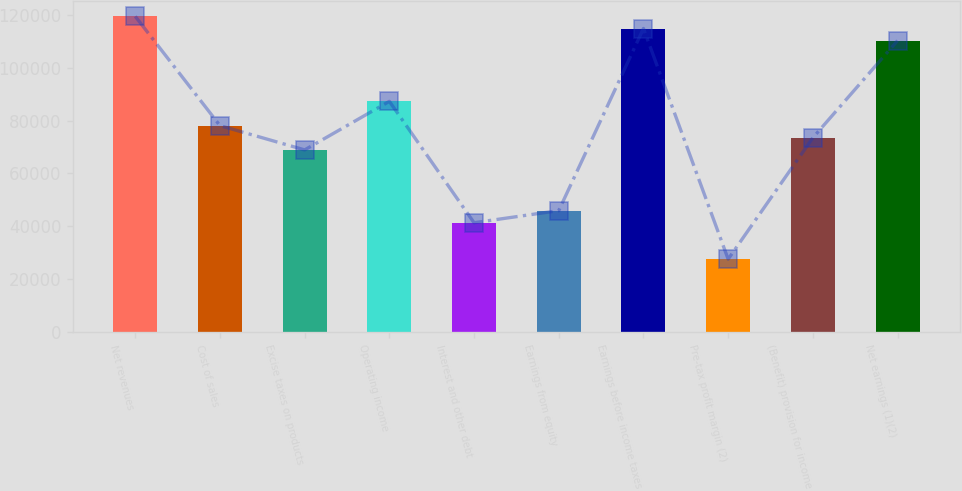Convert chart to OTSL. <chart><loc_0><loc_0><loc_500><loc_500><bar_chart><fcel>Net revenues<fcel>Cost of sales<fcel>Excise taxes on products<fcel>Operating income<fcel>Interest and other debt<fcel>Earnings from equity<fcel>Earnings before income taxes<fcel>Pre-tax profit margin (2)<fcel>(Benefit) provision for income<fcel>Net earnings (1)(2)<nl><fcel>119419<fcel>78082.8<fcel>68896.9<fcel>87268.7<fcel>41339<fcel>45932<fcel>114826<fcel>27560.2<fcel>73489.8<fcel>110234<nl></chart> 